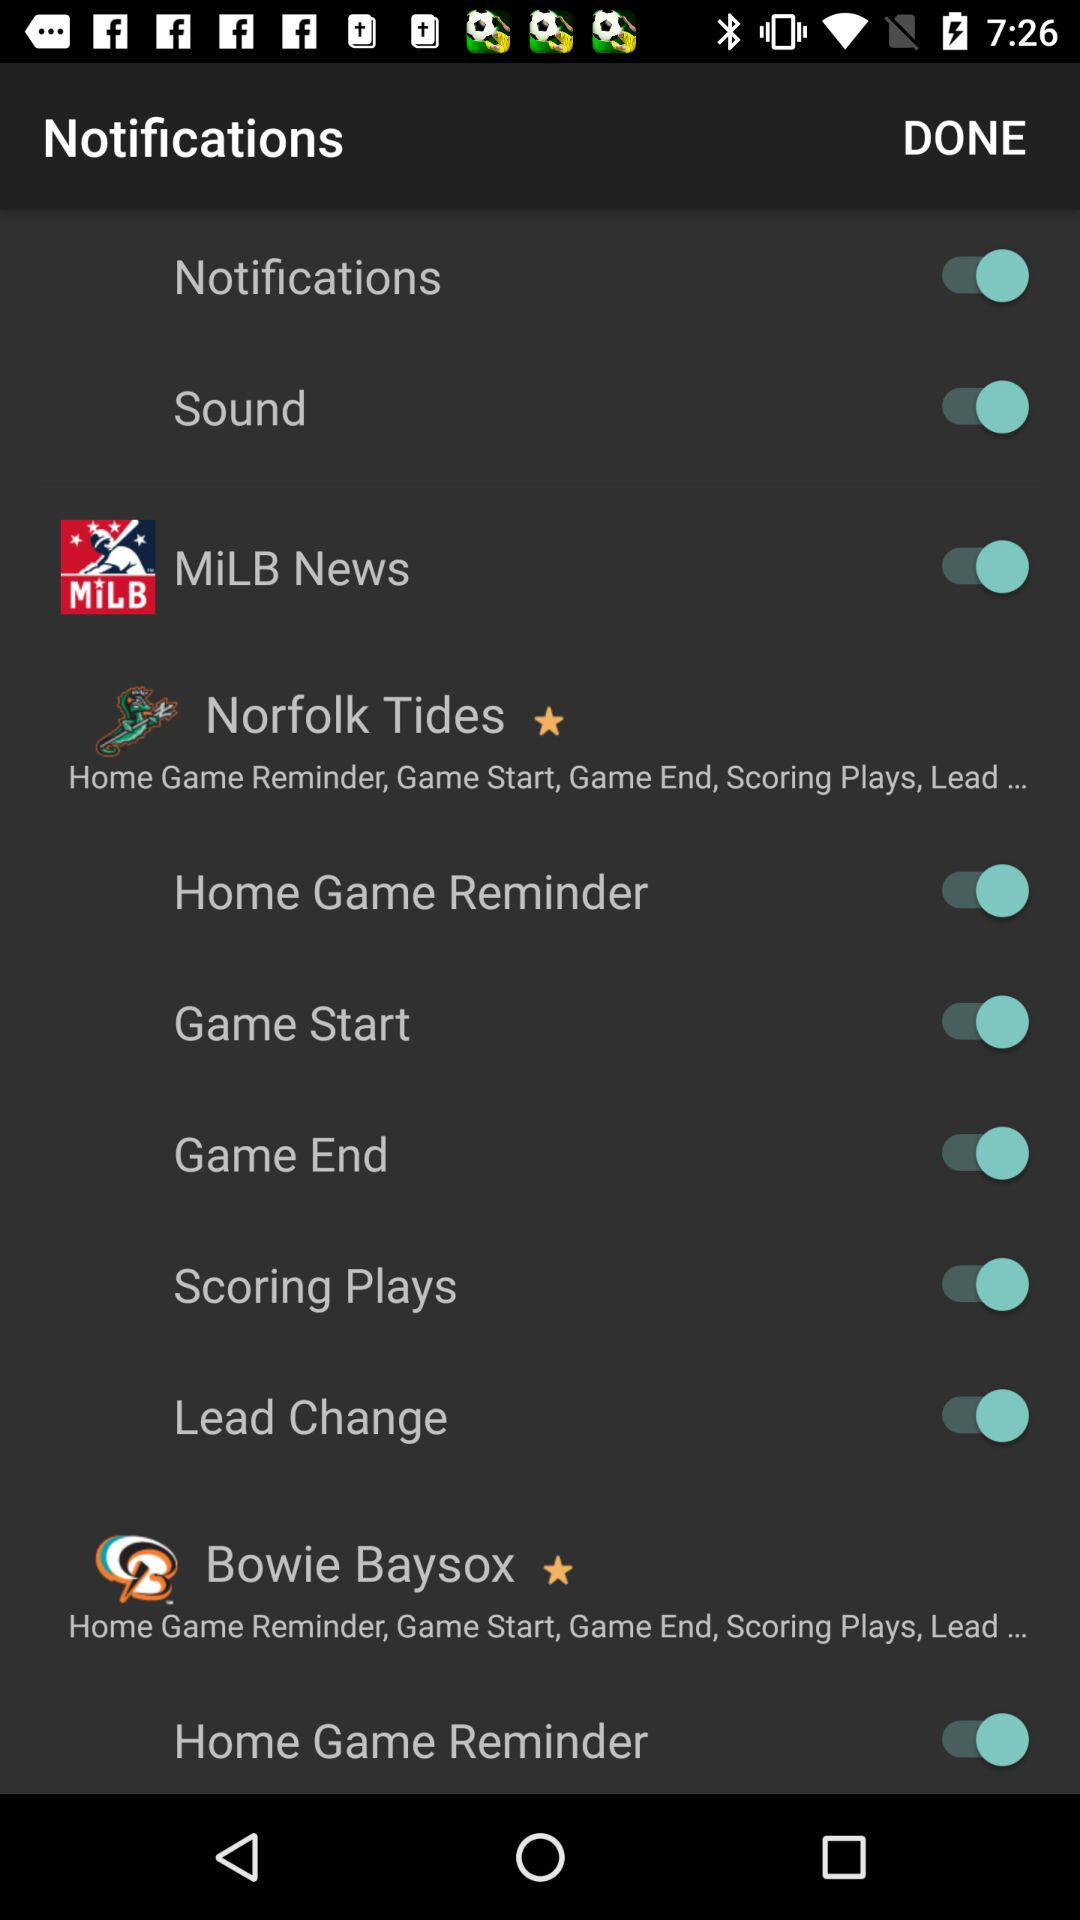What is the status of "Notifications"? The status of "Notifications" is "on". 